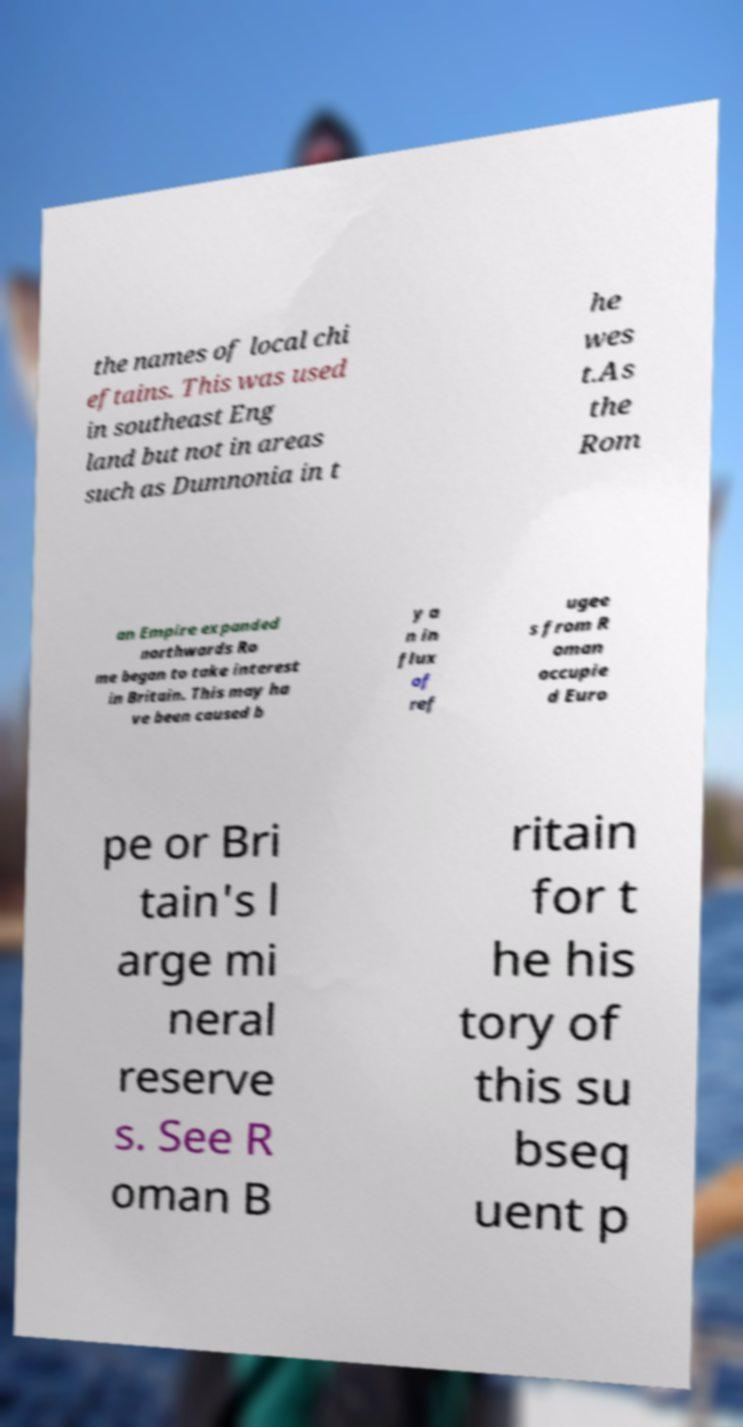There's text embedded in this image that I need extracted. Can you transcribe it verbatim? the names of local chi eftains. This was used in southeast Eng land but not in areas such as Dumnonia in t he wes t.As the Rom an Empire expanded northwards Ro me began to take interest in Britain. This may ha ve been caused b y a n in flux of ref ugee s from R oman occupie d Euro pe or Bri tain's l arge mi neral reserve s. See R oman B ritain for t he his tory of this su bseq uent p 